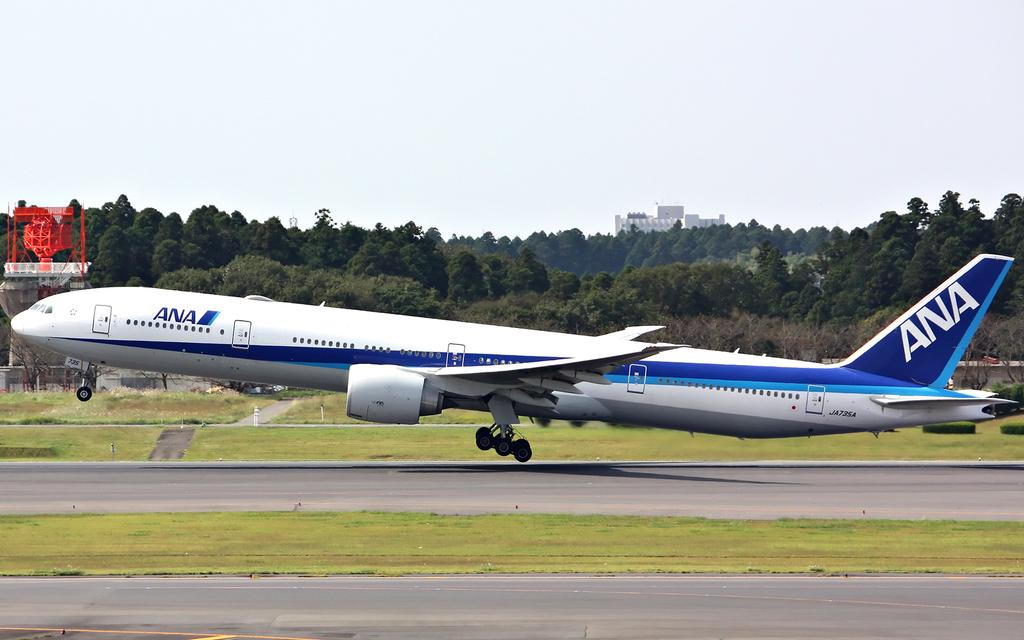<image>
Provide a brief description of the given image. An ANA airplane takes off from a runway 